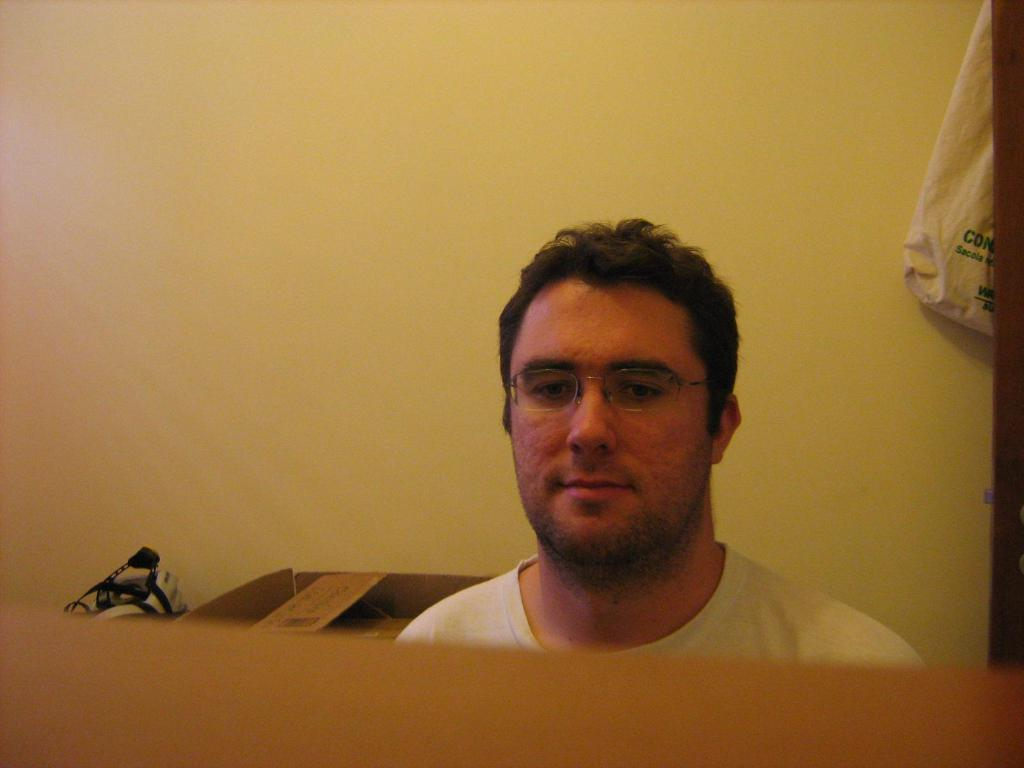Who is present in the image? There is a man in the image. What accessory is the man wearing? The man is wearing glasses (specs). What can be seen in the background of the image? There is a wall in the background of the image. How many dimes can be seen on the wall in the image? There are no dimes visible on the wall in the image. 